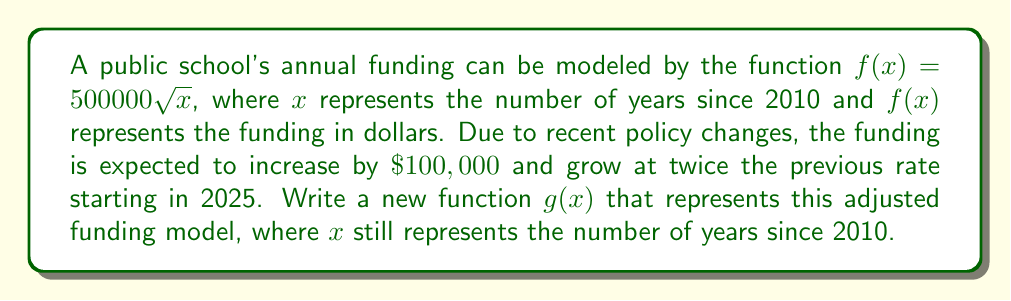What is the answer to this math problem? To transform the original function $f(x) = 500000 \sqrt{x}$ into the new function $g(x)$, we need to apply several transformations:

1. Vertical stretch: The growth rate is doubled, so we multiply the function by 2.
   $2f(x) = 2(500000 \sqrt{x}) = 1000000 \sqrt{x}$

2. Vertical shift: The funding is increased by $100,000, so we add 100000.
   $2f(x) + 100000 = 1000000 \sqrt{x} + 100000$

3. Horizontal shift: The changes start in 2025, which is 15 years after 2010. We need to shift the function 15 units to the left, replacing $x$ with $(x-15)$.

Combining these transformations, we get:
$g(x) = 1000000 \sqrt{x-15} + 100000$ for $x \geq 15$

Note that this function is only valid for $x \geq 15$, as the square root is undefined for negative values. For $x < 15$, the original function $f(x)$ would still apply.
Answer: $g(x) = 1000000 \sqrt{x-15} + 100000$ for $x \geq 15$ 